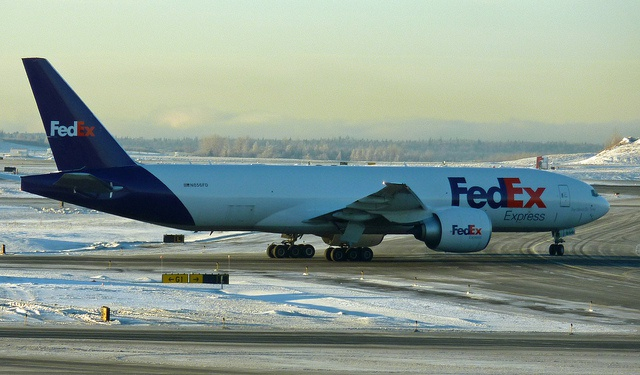Describe the objects in this image and their specific colors. I can see a airplane in beige, black, teal, blue, and navy tones in this image. 